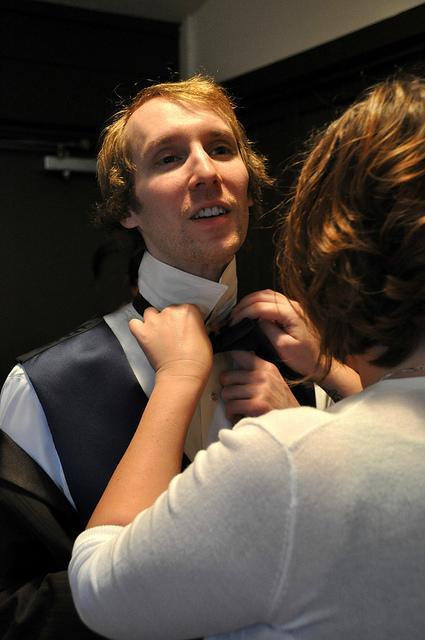What is the woman adjusting?
Select the accurate answer and provide justification: `Answer: choice
Rationale: srationale.`
Options: Her shoelaces, cats leash, dogs collar, tie. Answer: tie.
Rationale: A woman is reaching towards a man's neck who is wearing dress clothes. ties are commonly wore as part of dress clothes for men. 